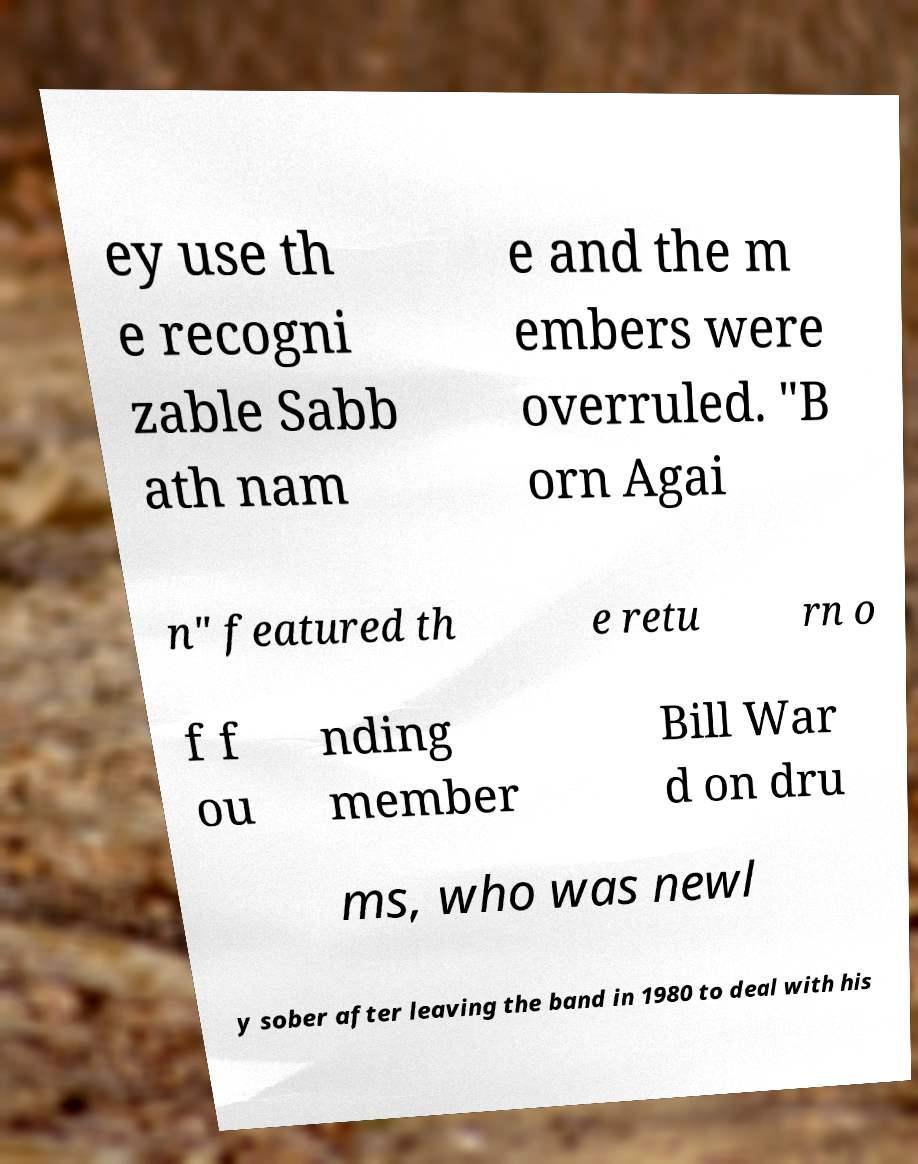Can you accurately transcribe the text from the provided image for me? ey use th e recogni zable Sabb ath nam e and the m embers were overruled. "B orn Agai n" featured th e retu rn o f f ou nding member Bill War d on dru ms, who was newl y sober after leaving the band in 1980 to deal with his 